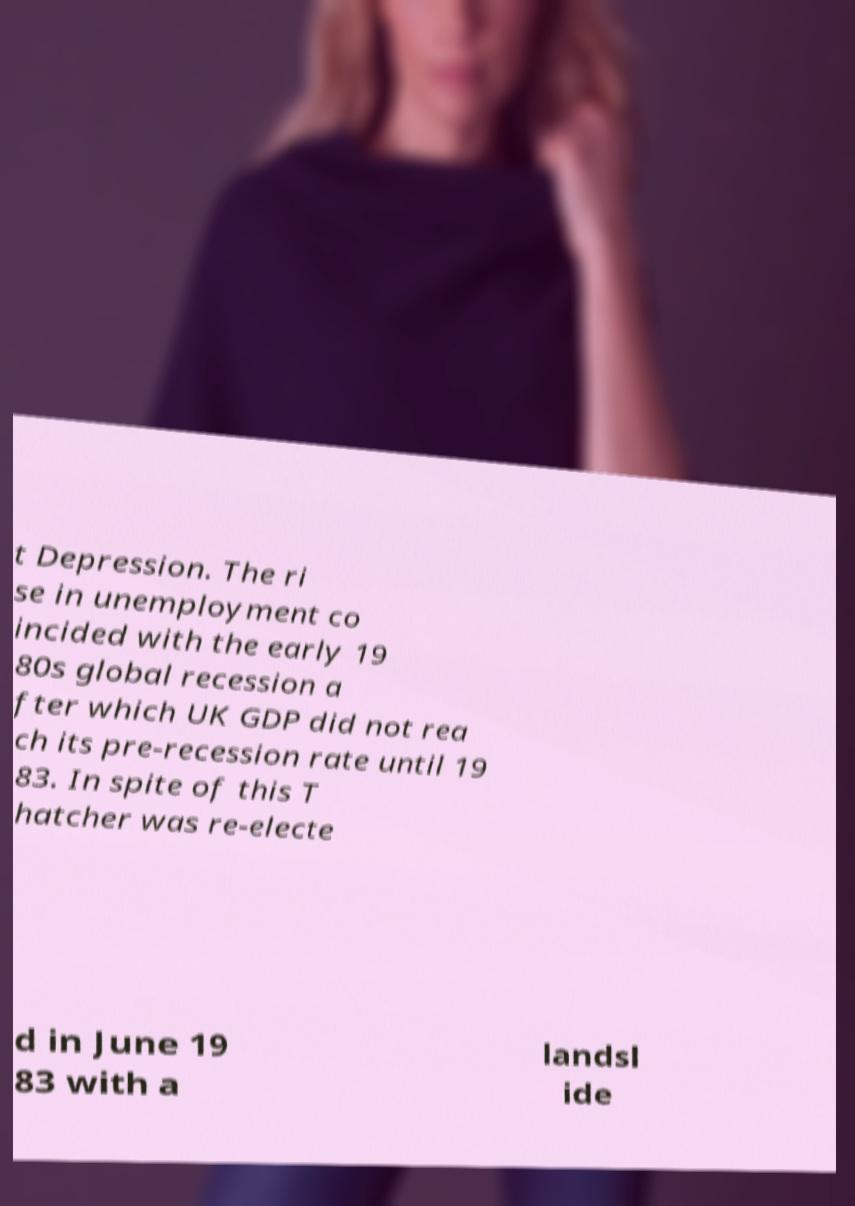What messages or text are displayed in this image? I need them in a readable, typed format. t Depression. The ri se in unemployment co incided with the early 19 80s global recession a fter which UK GDP did not rea ch its pre-recession rate until 19 83. In spite of this T hatcher was re-electe d in June 19 83 with a landsl ide 